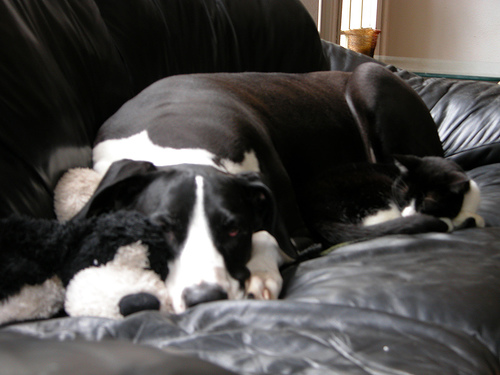What kind of mood does this image evoke? The image evokes a sense of tranquility and peaceful coexistence, showing the dog and cat in a calm, resting pose that suggests comfort and serenity. 